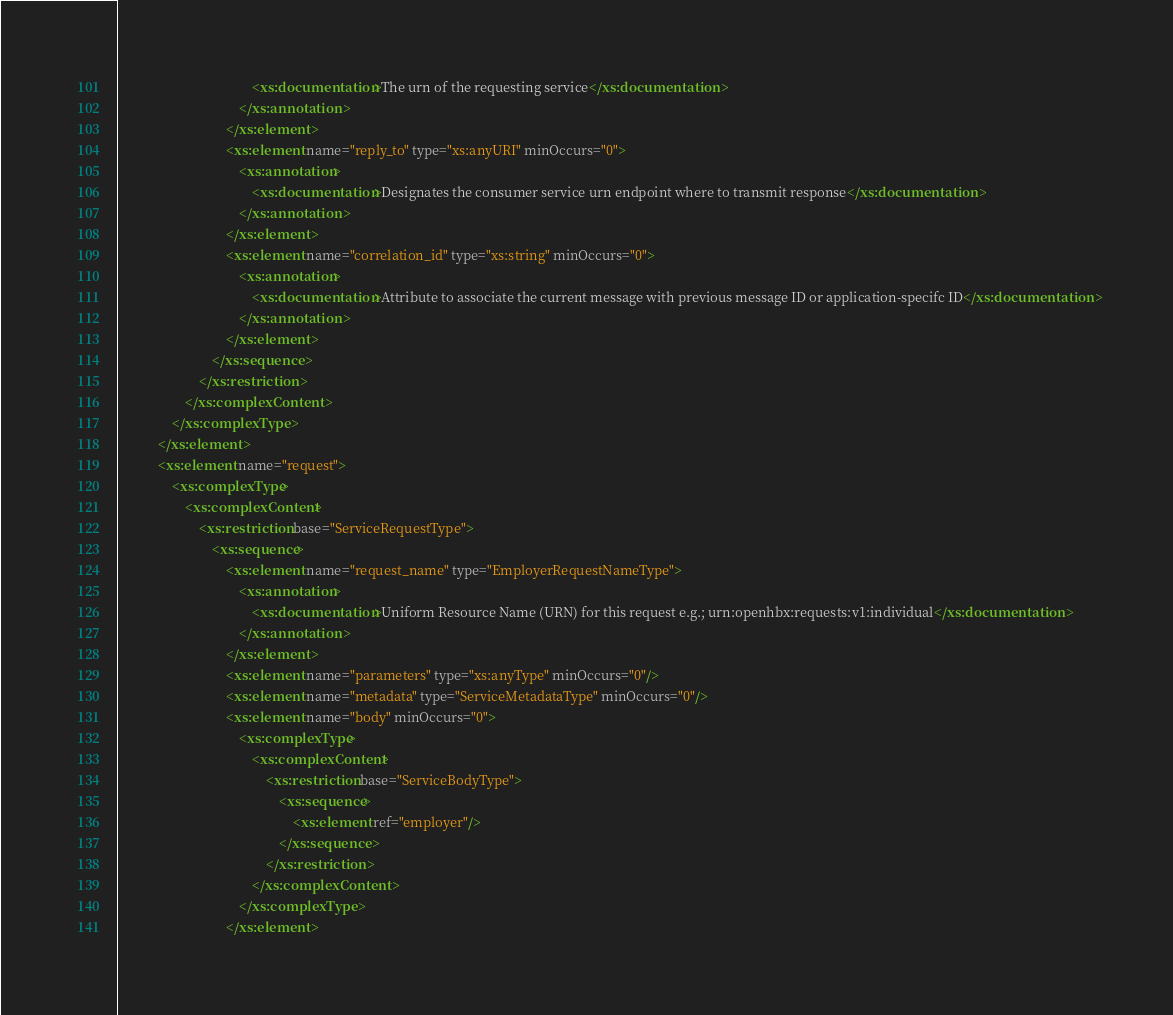<code> <loc_0><loc_0><loc_500><loc_500><_XML_>										<xs:documentation>The urn of the requesting service</xs:documentation>
									</xs:annotation>
								</xs:element>
								<xs:element name="reply_to" type="xs:anyURI" minOccurs="0">
									<xs:annotation>
										<xs:documentation>Designates the consumer service urn endpoint where to transmit response</xs:documentation>
									</xs:annotation>
								</xs:element>
								<xs:element name="correlation_id" type="xs:string" minOccurs="0">
									<xs:annotation>
										<xs:documentation>Attribute to associate the current message with previous message ID or application-specifc ID</xs:documentation>
									</xs:annotation>
								</xs:element>
							</xs:sequence>
						</xs:restriction>
					</xs:complexContent>
				</xs:complexType>
			</xs:element>
			<xs:element name="request">
				<xs:complexType>
					<xs:complexContent>
						<xs:restriction base="ServiceRequestType">
							<xs:sequence>
								<xs:element name="request_name" type="EmployerRequestNameType">
									<xs:annotation>
										<xs:documentation>Uniform Resource Name (URN) for this request e.g.; urn:openhbx:requests:v1:individual</xs:documentation>
									</xs:annotation>
								</xs:element>
								<xs:element name="parameters" type="xs:anyType" minOccurs="0"/>
								<xs:element name="metadata" type="ServiceMetadataType" minOccurs="0"/>
								<xs:element name="body" minOccurs="0">
									<xs:complexType>
										<xs:complexContent>
											<xs:restriction base="ServiceBodyType">
												<xs:sequence>
													<xs:element ref="employer"/>
												</xs:sequence>
											</xs:restriction>
										</xs:complexContent>
									</xs:complexType>
								</xs:element></code> 